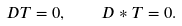Convert formula to latex. <formula><loc_0><loc_0><loc_500><loc_500>D T = 0 , \quad D * T = 0 .</formula> 